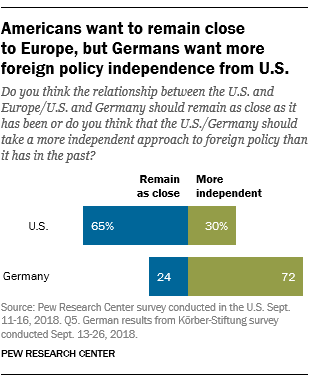Mention a couple of crucial points in this snapshot. The top blue bar has a percentage value of 65%. The ratio of the smallest to largest green bar is 0.216666667, indicating that the green bars in the image are not evenly distributed. 